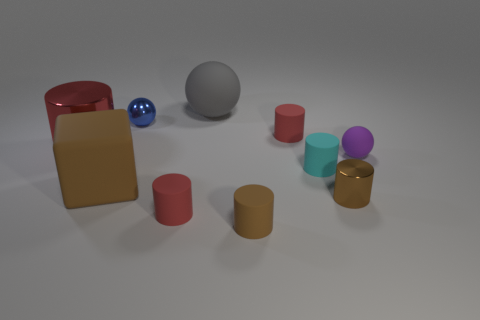What is the material of the object that is both right of the gray rubber ball and behind the purple matte sphere? rubber 